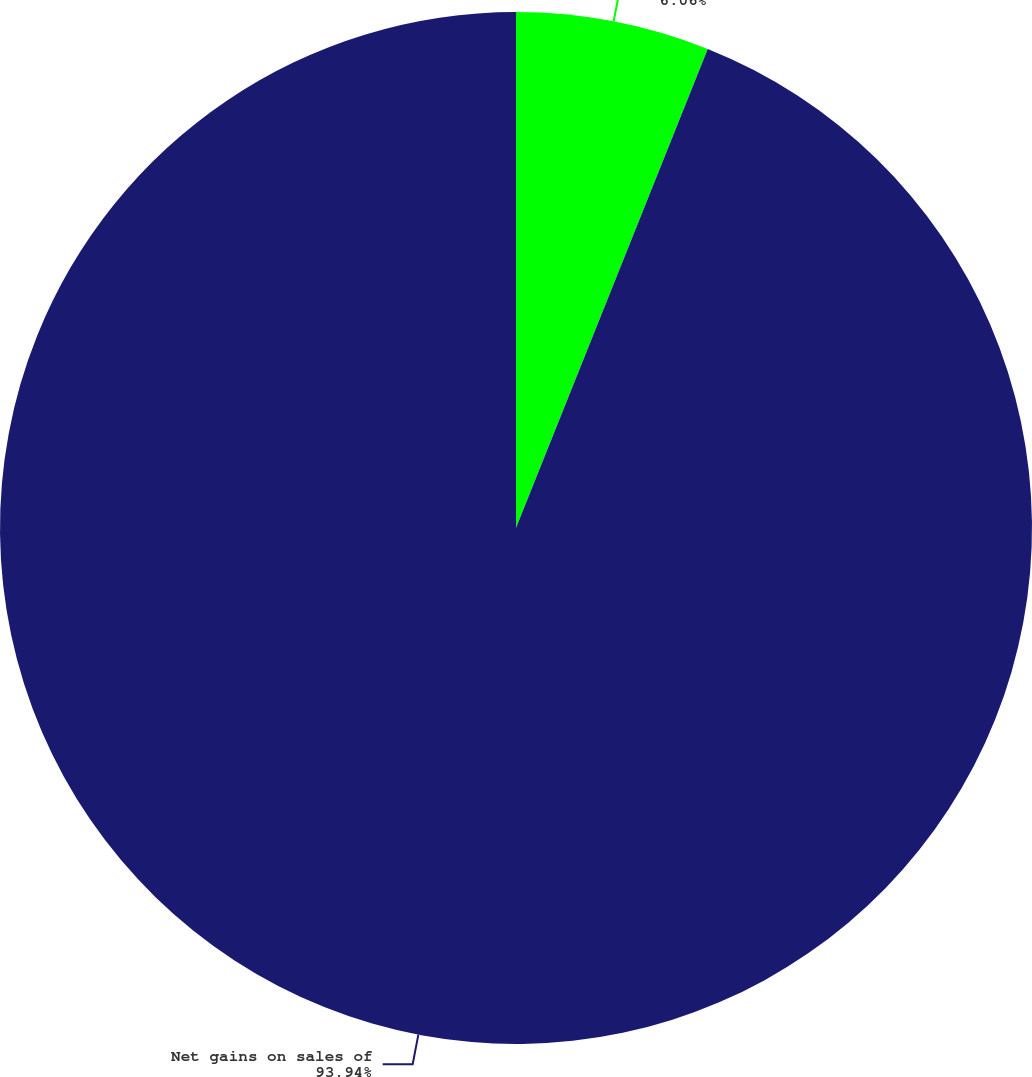Convert chart to OTSL. <chart><loc_0><loc_0><loc_500><loc_500><pie_chart><fcel>Private equity gains/(losses)<fcel>Net gains on sales of<nl><fcel>6.06%<fcel>93.94%<nl></chart> 